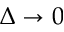Convert formula to latex. <formula><loc_0><loc_0><loc_500><loc_500>\Delta \rightarrow 0</formula> 